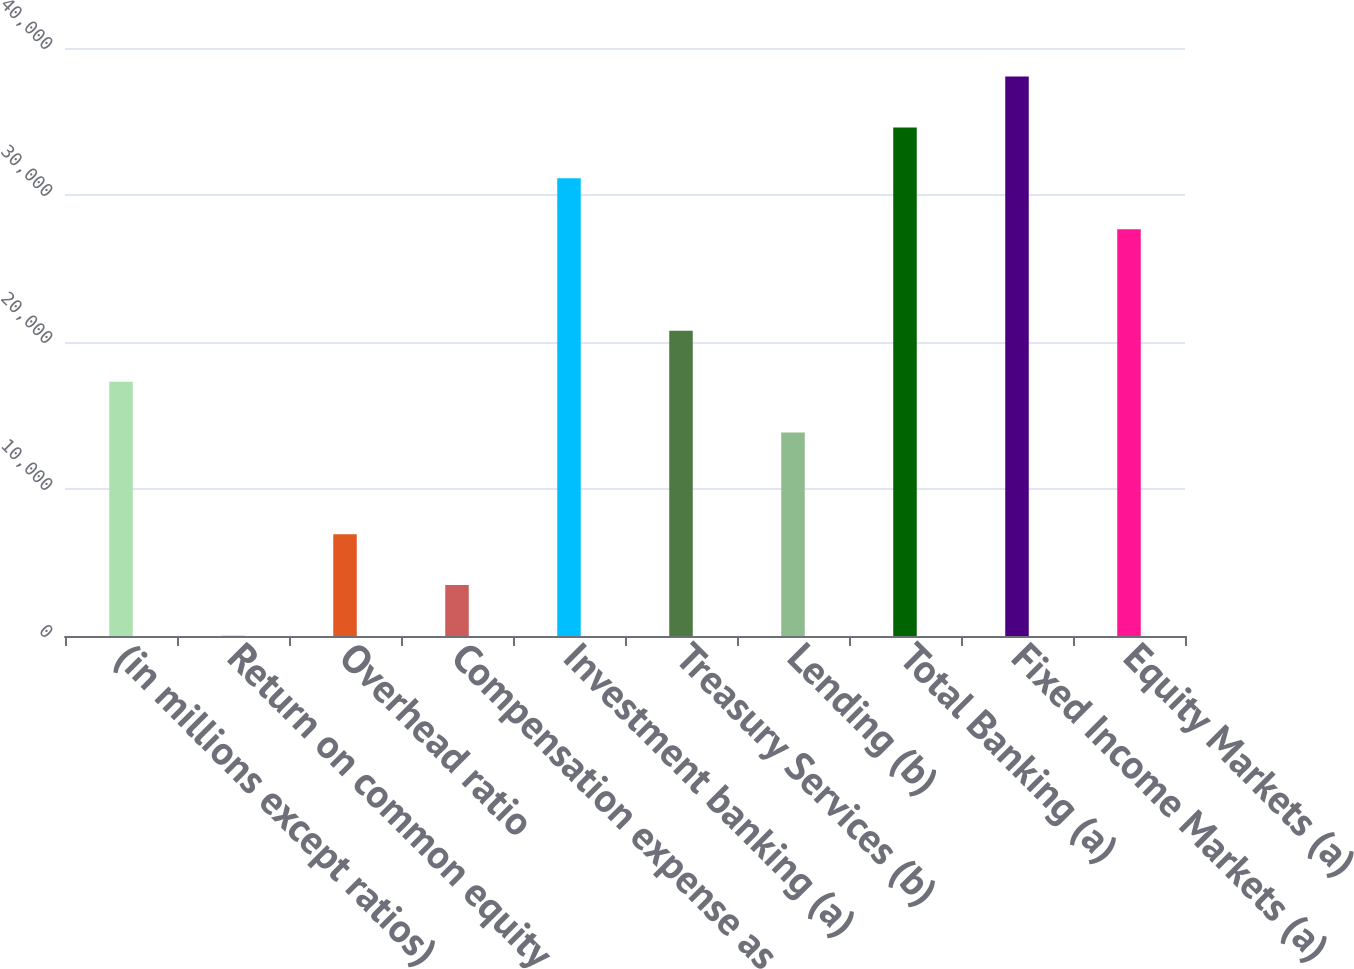<chart> <loc_0><loc_0><loc_500><loc_500><bar_chart><fcel>(in millions except ratios)<fcel>Return on common equity<fcel>Overhead ratio<fcel>Compensation expense as<fcel>Investment banking (a)<fcel>Treasury Services (b)<fcel>Lending (b)<fcel>Total Banking (a)<fcel>Fixed Income Markets (a)<fcel>Equity Markets (a)<nl><fcel>17302.5<fcel>10<fcel>6927<fcel>3468.5<fcel>31136.5<fcel>20761<fcel>13844<fcel>34595<fcel>38053.5<fcel>27678<nl></chart> 